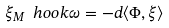<formula> <loc_0><loc_0><loc_500><loc_500>\label l { e \colon H a m } \xi _ { M } \ h o o k \omega = - d \langle \Phi , \xi \rangle</formula> 